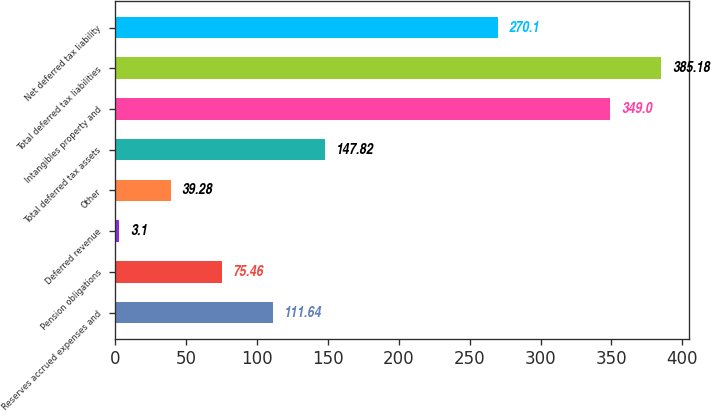<chart> <loc_0><loc_0><loc_500><loc_500><bar_chart><fcel>Reserves accrued expenses and<fcel>Pension obligations<fcel>Deferred revenue<fcel>Other<fcel>Total deferred tax assets<fcel>Intangibles property and<fcel>Total deferred tax liabilities<fcel>Net deferred tax liability<nl><fcel>111.64<fcel>75.46<fcel>3.1<fcel>39.28<fcel>147.82<fcel>349<fcel>385.18<fcel>270.1<nl></chart> 